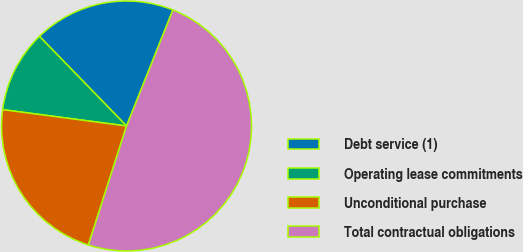<chart> <loc_0><loc_0><loc_500><loc_500><pie_chart><fcel>Debt service (1)<fcel>Operating lease commitments<fcel>Unconditional purchase<fcel>Total contractual obligations<nl><fcel>18.32%<fcel>10.64%<fcel>22.15%<fcel>48.89%<nl></chart> 